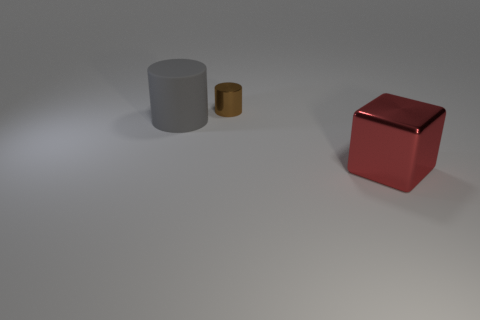Add 1 tiny metal cylinders. How many objects exist? 4 Subtract 1 cylinders. How many cylinders are left? 1 Add 2 tiny cylinders. How many tiny cylinders are left? 3 Add 3 big gray cylinders. How many big gray cylinders exist? 4 Subtract 0 red cylinders. How many objects are left? 3 Subtract all cylinders. How many objects are left? 1 Subtract all brown blocks. Subtract all green spheres. How many blocks are left? 1 Subtract all yellow metallic cylinders. Subtract all large gray rubber objects. How many objects are left? 2 